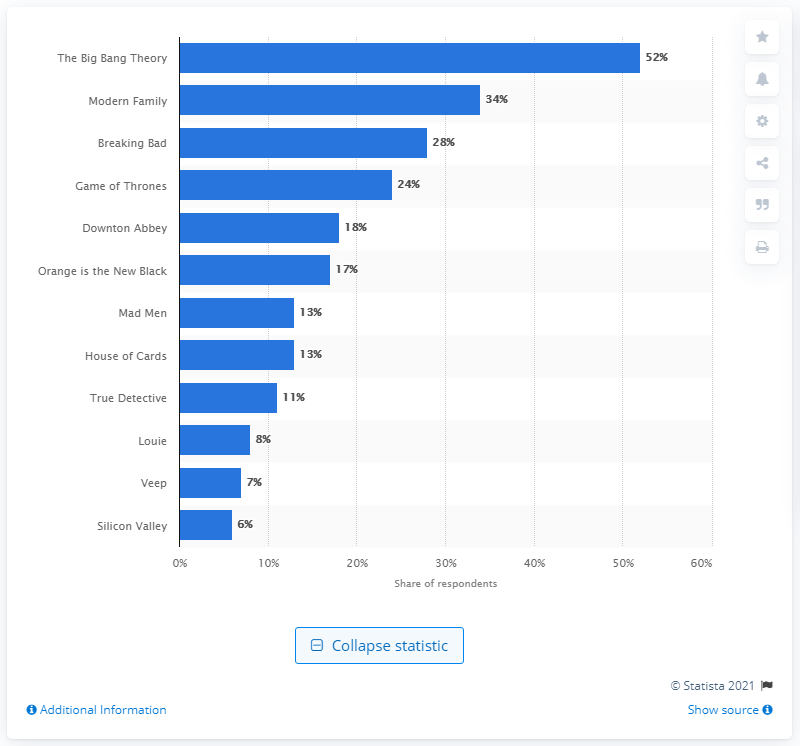Draw attention to some important aspects in this diagram. According to the survey, a significant 24% of respondents revealed that they had watched a fantasy series. The most popular response was Game of Thrones. 